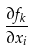<formula> <loc_0><loc_0><loc_500><loc_500>\frac { \partial f _ { k } } { \partial x _ { i } }</formula> 